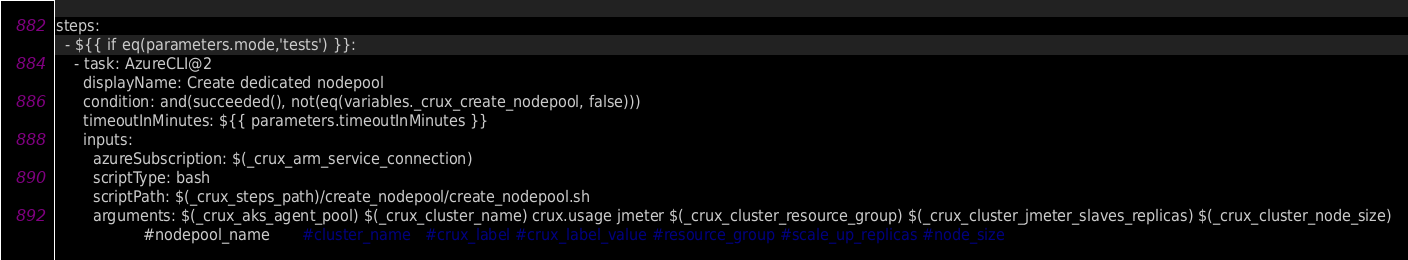Convert code to text. <code><loc_0><loc_0><loc_500><loc_500><_YAML_>
steps:
  - ${{ if eq(parameters.mode,'tests') }}:
    - task: AzureCLI@2
      displayName: Create dedicated nodepool
      condition: and(succeeded(), not(eq(variables._crux_create_nodepool, false)))
      timeoutInMinutes: ${{ parameters.timeoutInMinutes }}
      inputs:
        azureSubscription: $(_crux_arm_service_connection)
        scriptType: bash
        scriptPath: $(_crux_steps_path)/create_nodepool/create_nodepool.sh
        arguments: $(_crux_aks_agent_pool) $(_crux_cluster_name) crux.usage jmeter $(_crux_cluster_resource_group) $(_crux_cluster_jmeter_slaves_replicas) $(_crux_cluster_node_size)
                   #nodepool_name       #cluster_name   #crux_label #crux_label_value #resource_group #scale_up_replicas #node_size</code> 